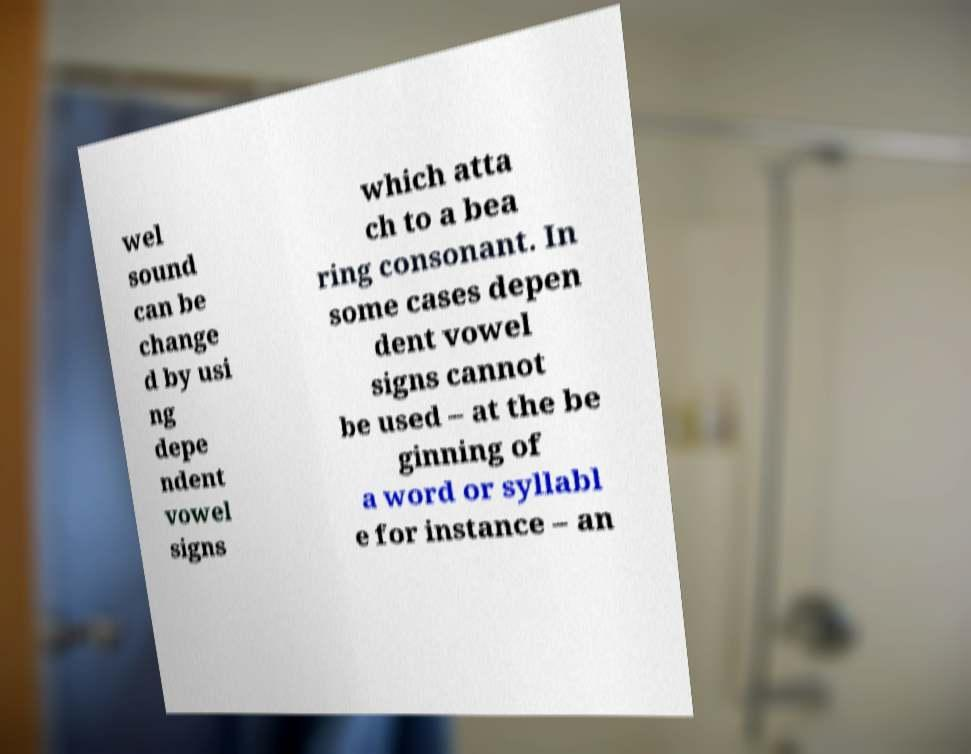For documentation purposes, I need the text within this image transcribed. Could you provide that? wel sound can be change d by usi ng depe ndent vowel signs which atta ch to a bea ring consonant. In some cases depen dent vowel signs cannot be used – at the be ginning of a word or syllabl e for instance – an 